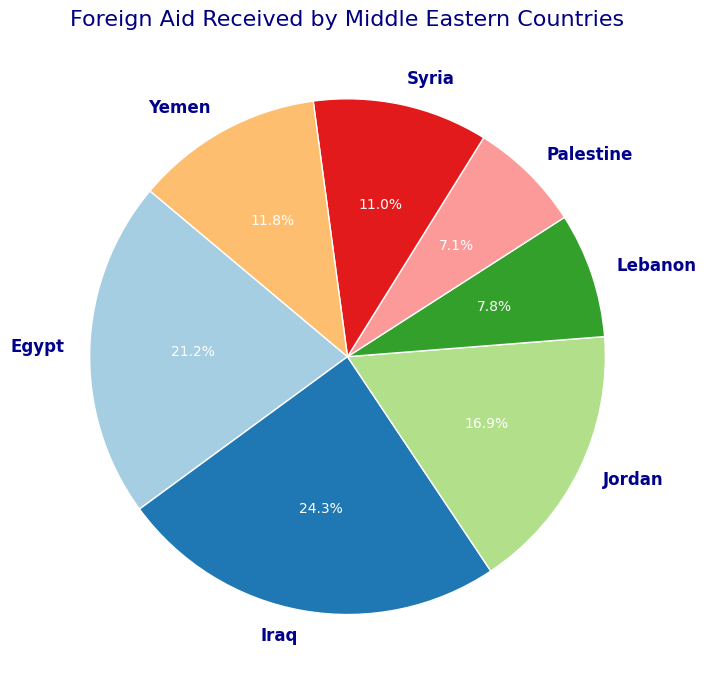What percentage of the total foreign aid is received by Egypt? First, identify the slice corresponding to Egypt in the pie chart. This slice represents Egypt receiving 27.2% of the total foreign aid according to the chart legend.
Answer: 27.2% Which country received the highest amount of foreign aid? Look at the slices in the pie chart and identify the largest one. Iraq has the largest slice.
Answer: Iraq Between Jordan and Yemen, which country received more foreign aid? Compare the slices representing Jordan and Yemen in the pie chart. Jordan's slice is larger than Yemen's.
Answer: Jordan What is the combined percentage of foreign aid received by Lebanon and Palestine? Find the percentages for Lebanon and Palestine from the pie chart: Lebanon 9.0%, Palestine 6.3%. Add these values: 9.0% + 6.3% = 15.3%.
Answer: 15.3% What percentage of the total foreign aid does the United States contribute, assuming the pie chart shows only the amount received? Identify the contributions of the United States from each country's aid and recognize the overall pattern in the pie chart, suggesting indirect but significant contributions.
Answer: A large portion Which country has the smallest share of foreign aid? Find the smallest slice in the pie chart. Palestine has the smallest share.
Answer: Palestine What is the difference in foreign aid received by Syria and Yemen? From the pie chart, Syria 9.0%, Yemen 10.2%. Subtract: 10.2% - 9.0% = 1.2%.
Answer: 1.2% Which countries received more aid than Lebanon? Identify Lebanon's slice (9.0%) and compare it with others. Countries with more are Egypt (27.2%), Iraq (23.4%), Jordan (18.7%).
Answer: Egypt, Iraq, Jordan Among the countries listed, which two received an almost equal amount of foreign aid? Compare the sizes of slices, looking for similarly sized ones. Lebanon 9.0%, Syria 9.0% are the closest in size.
Answer: Lebanon, Syria 